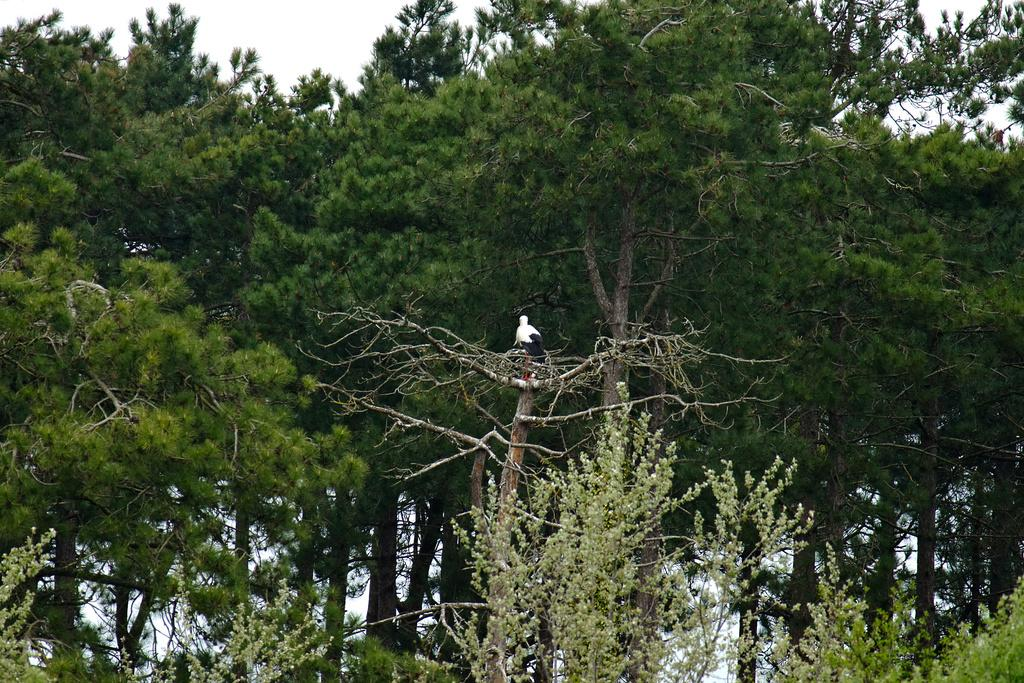What type of animal is in the image? There is a bird in the image. Where is the bird located? The bird is on a tree. What colors can be seen on the bird? The bird has both white and black colors. What can be seen in the background of the image? There are trees visible in the background of the image. What is visible at the top of the image? The sky is visible at the top of the image. How many cows are visible in the image? There are no cows present in the image; it features a bird on a tree. What type of grape is the bird holding in its beak? There is no grape present in the image, and birds do not hold objects in their beaks. 